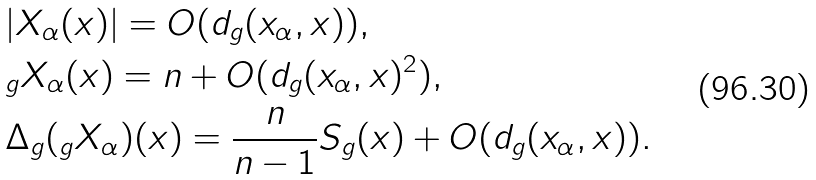Convert formula to latex. <formula><loc_0><loc_0><loc_500><loc_500>& | X _ { \alpha } ( x ) | = O ( d _ { g } ( x _ { \alpha } , x ) ) , \\ & _ { g } X _ { \alpha } ( x ) = n + O ( d _ { g } ( x _ { \alpha } , x ) ^ { 2 } ) , \\ & \Delta _ { g } ( _ { g } X _ { \alpha } ) ( x ) = \frac { n } { n - 1 } S _ { g } ( x ) + O ( d _ { g } ( x _ { \alpha } , x ) ) .</formula> 